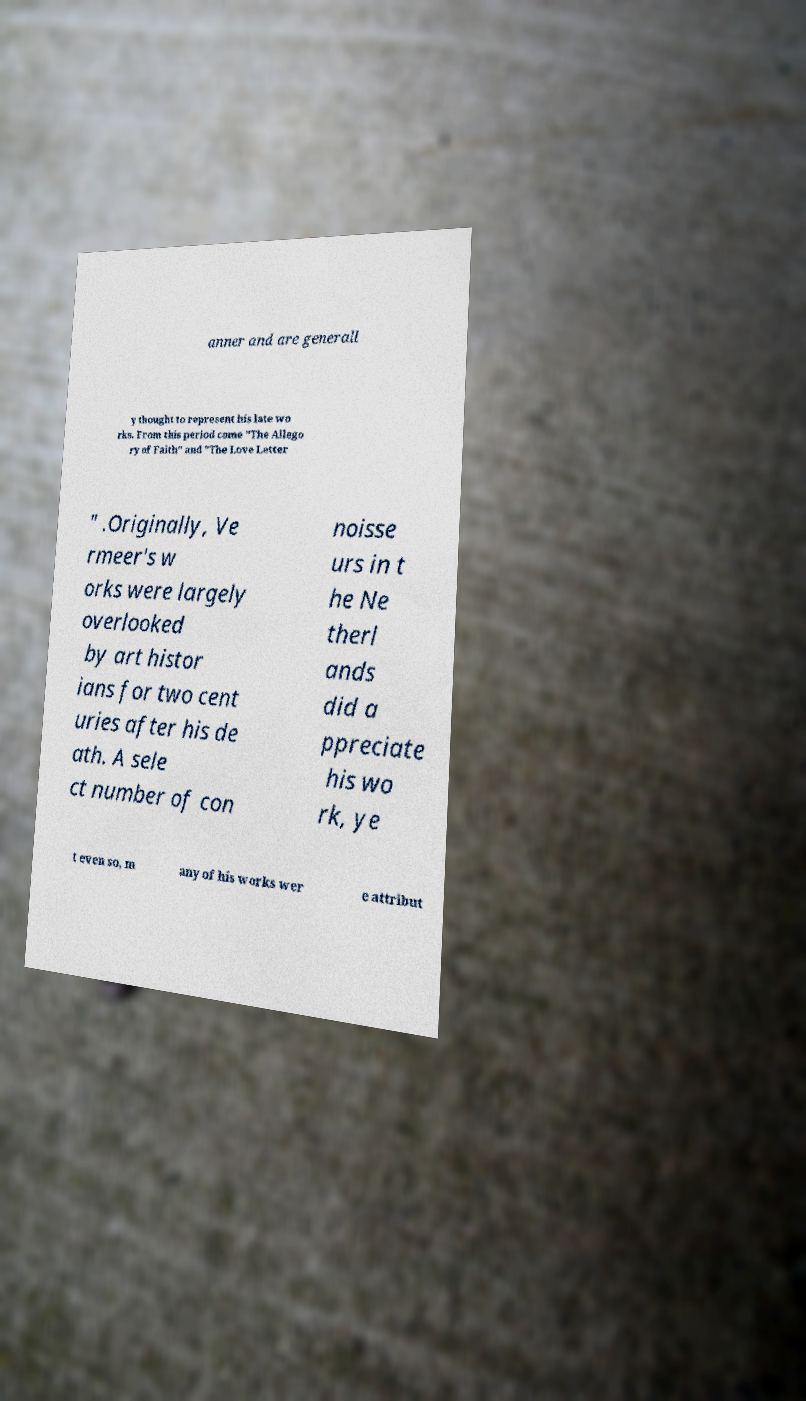For documentation purposes, I need the text within this image transcribed. Could you provide that? anner and are generall y thought to represent his late wo rks. From this period come "The Allego ry of Faith" and "The Love Letter " .Originally, Ve rmeer's w orks were largely overlooked by art histor ians for two cent uries after his de ath. A sele ct number of con noisse urs in t he Ne therl ands did a ppreciate his wo rk, ye t even so, m any of his works wer e attribut 